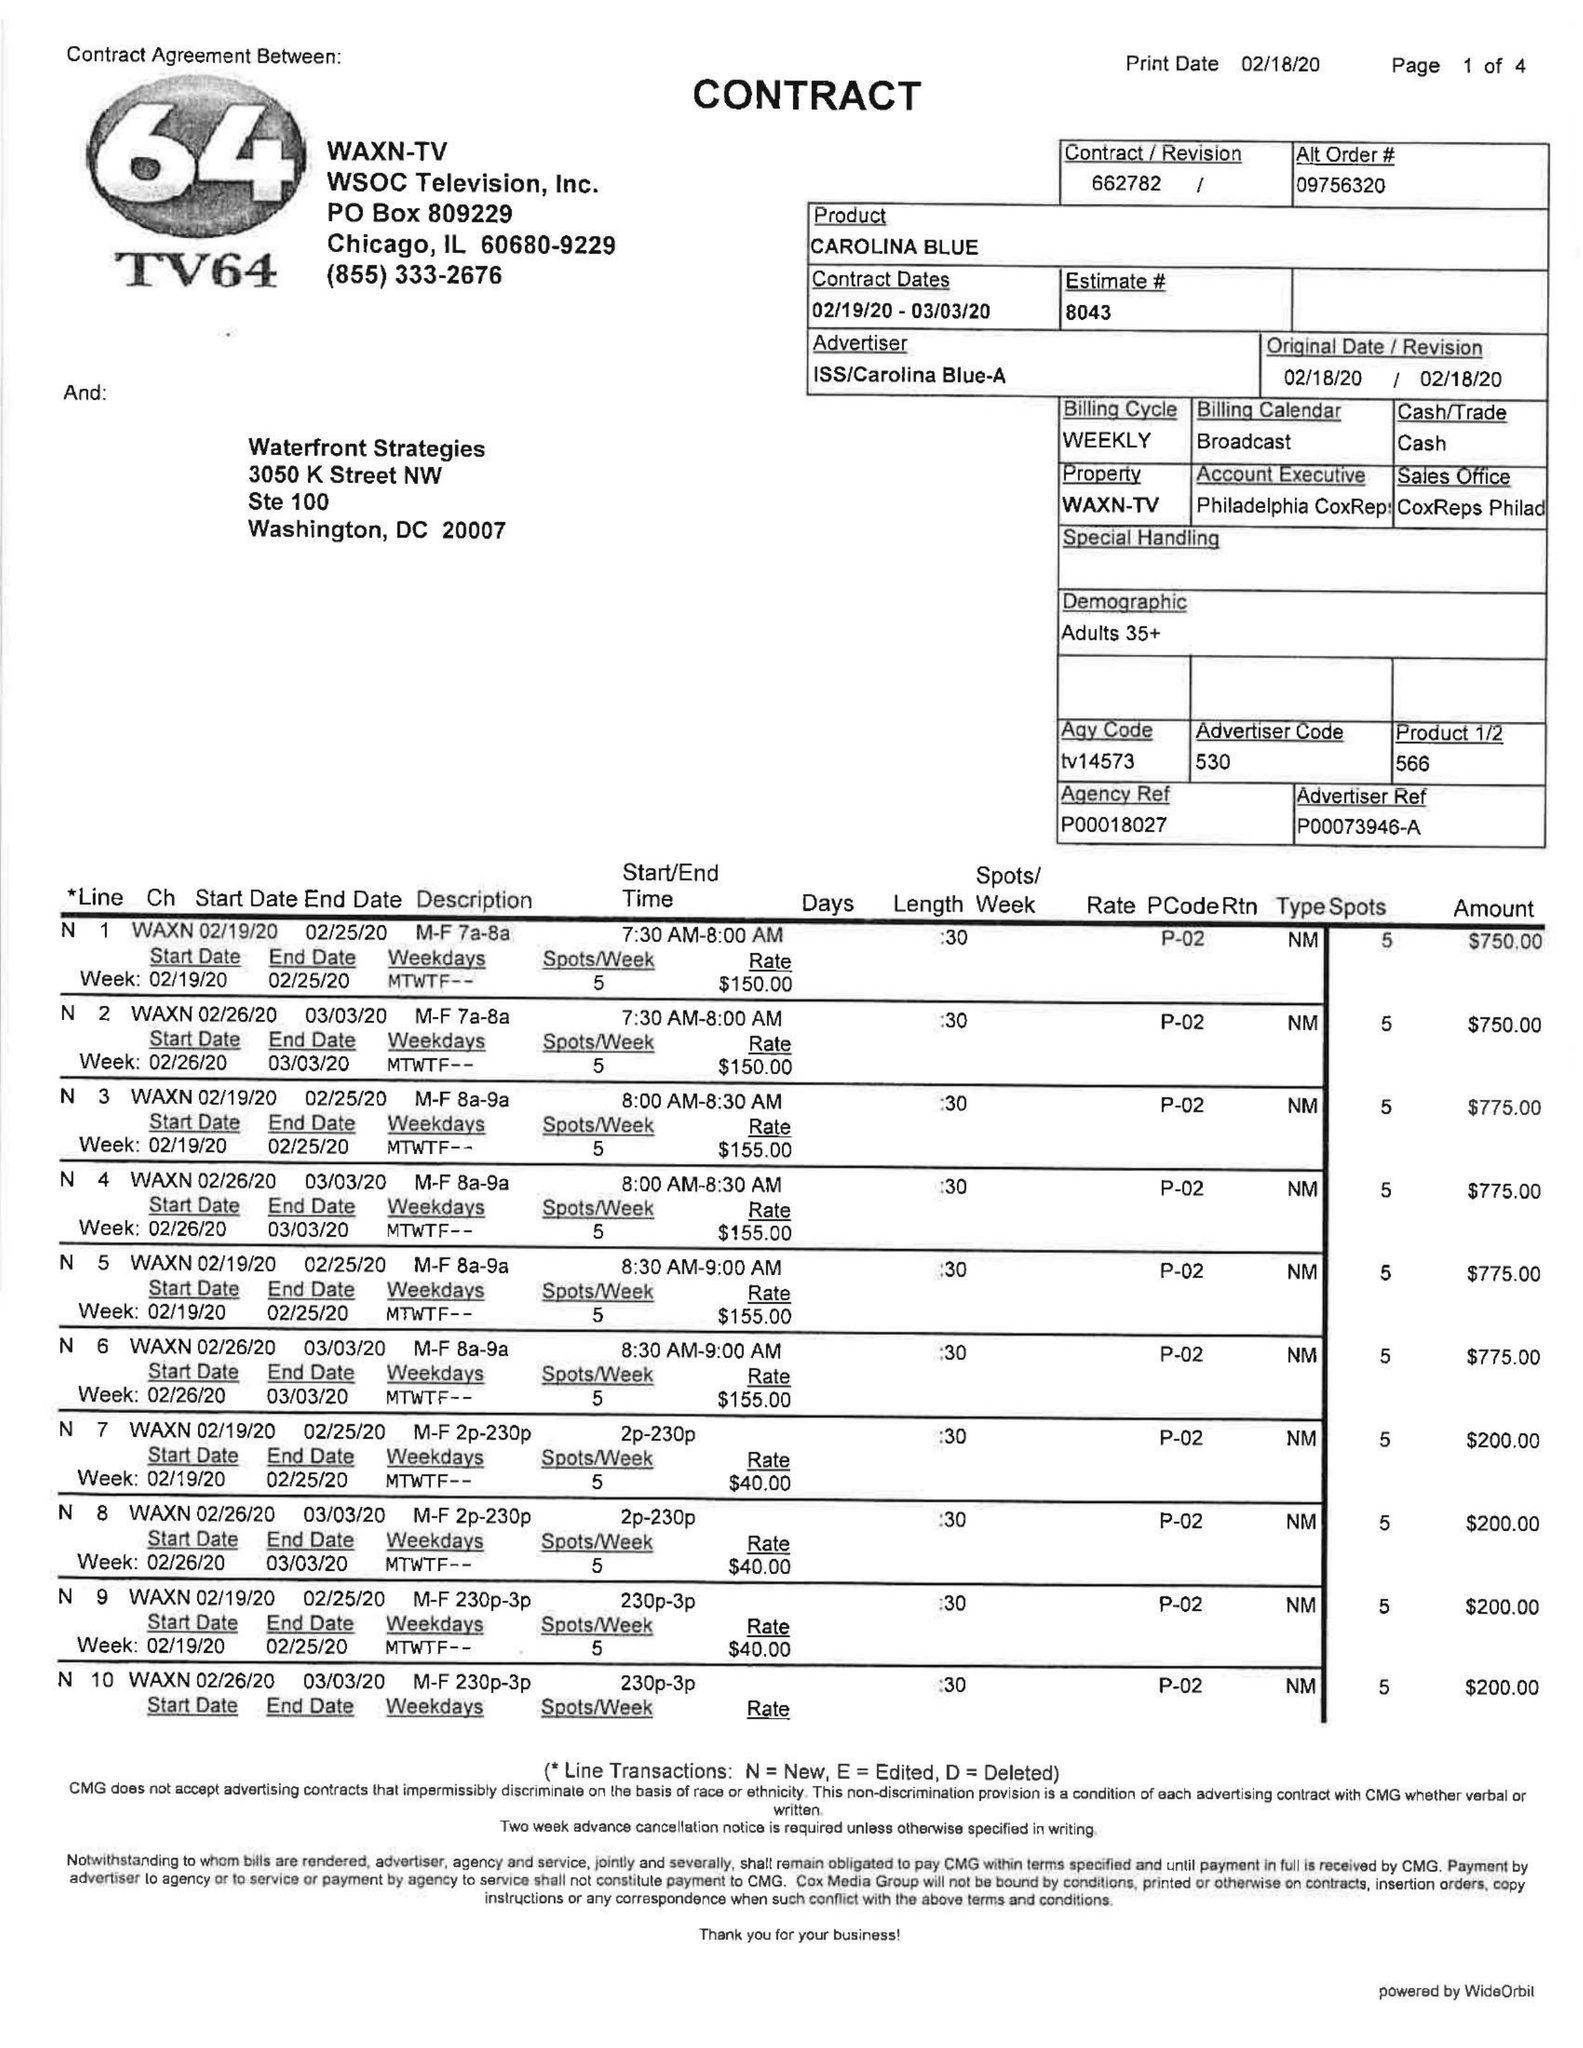What is the value for the advertiser?
Answer the question using a single word or phrase. ISS/CAROLINABLUE-A 